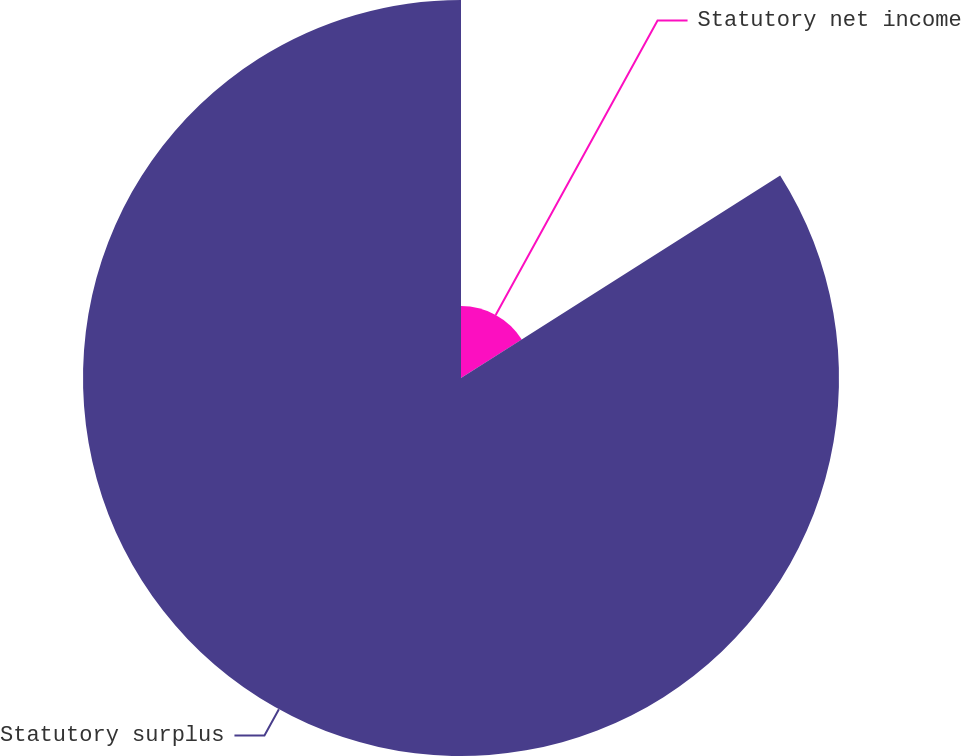<chart> <loc_0><loc_0><loc_500><loc_500><pie_chart><fcel>Statutory net income<fcel>Statutory surplus<nl><fcel>16.0%<fcel>84.0%<nl></chart> 